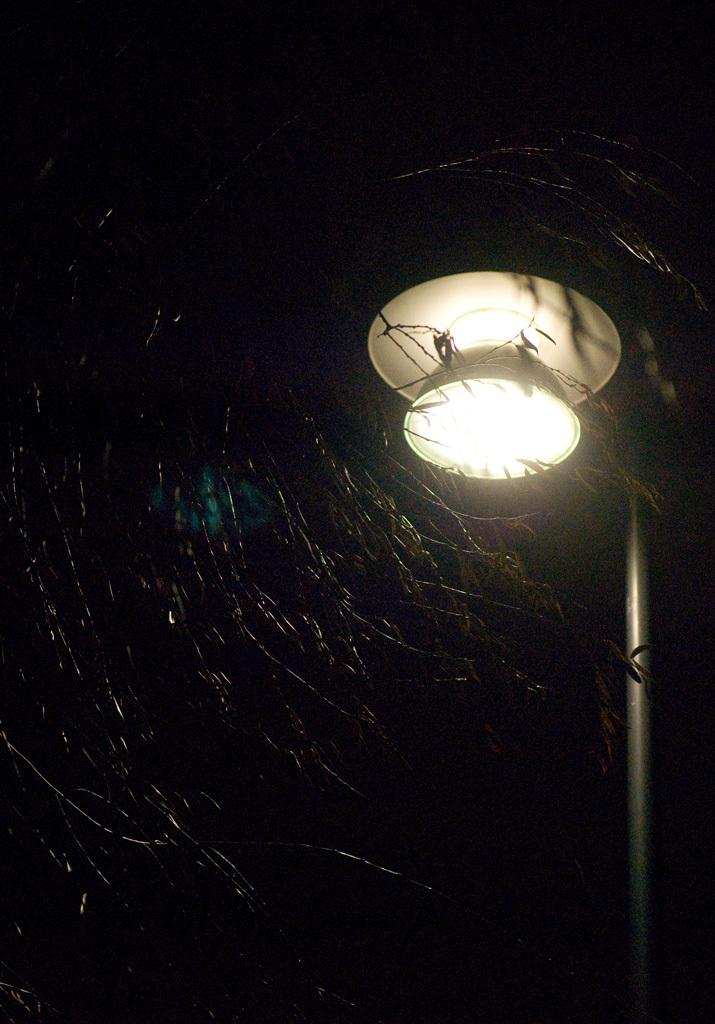What type of structure can be seen in the image? There is a street light in the image. What is the pole used for in the image? The pole is likely used to support the street light in the image. What type of vegetation is present in the image? There are trees in the image. What trick is being performed by the trees in the image? There is no trick being performed by the trees in the image; they are simply standing as part of the natural environment. 